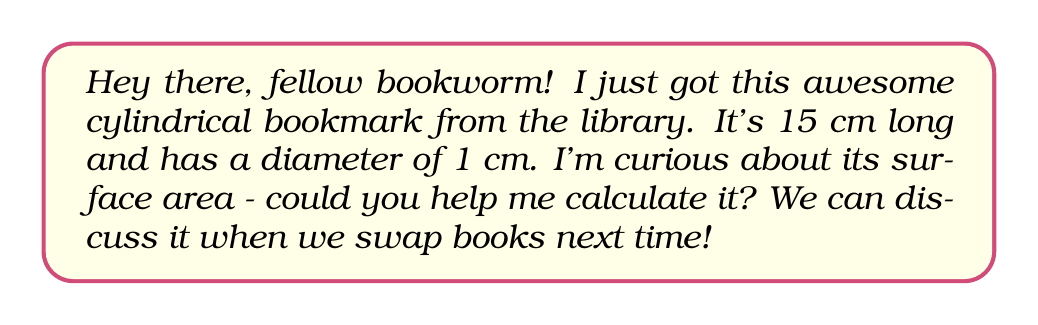Help me with this question. Sure! Let's break this down step-by-step:

1) A cylinder has three surfaces: two circular ends and a curved lateral surface.

2) For the circular ends:
   - The radius is half the diameter: $r = 0.5$ cm
   - Area of one circular end: $A_{circle} = \pi r^2 = \pi (0.5)^2 = 0.25\pi$ cm²
   - There are two circular ends, so total area of ends: $2 \times 0.25\pi = 0.5\pi$ cm²

3) For the curved lateral surface:
   - This is a rectangle when "unrolled"
   - Width of rectangle = circumference of circle = $2\pi r = 2\pi (0.5) = \pi$ cm
   - Length of rectangle = length of cylinder = 15 cm
   - Area of rectangle = $15\pi$ cm²

4) Total surface area:
   $SA_{total} = SA_{ends} + SA_{lateral}$
   $SA_{total} = 0.5\pi + 15\pi = 15.5\pi$ cm²

Therefore, the surface area of the bookmark is $15.5\pi$ square centimeters.
Answer: $15.5\pi$ cm² or approximately 48.69 cm² 